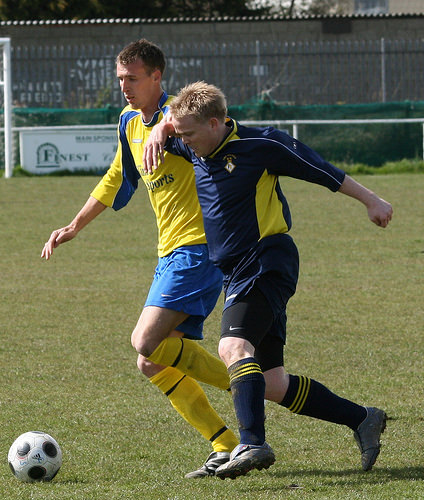<image>
Is the man to the left of the man? Yes. From this viewpoint, the man is positioned to the left side relative to the man. Is there a ball to the left of the player? Yes. From this viewpoint, the ball is positioned to the left side relative to the player. Where is the man in relation to the ball? Is it in front of the ball? Yes. The man is positioned in front of the ball, appearing closer to the camera viewpoint. 